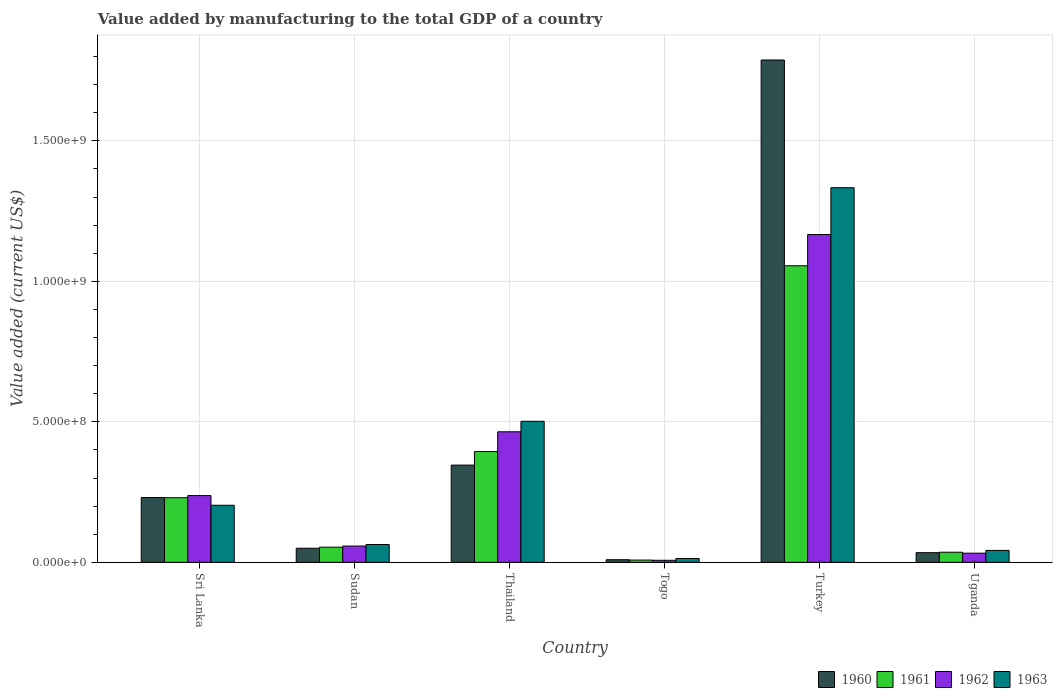Are the number of bars on each tick of the X-axis equal?
Provide a short and direct response. Yes. How many bars are there on the 4th tick from the left?
Your answer should be very brief. 4. How many bars are there on the 2nd tick from the right?
Offer a terse response. 4. What is the label of the 5th group of bars from the left?
Your answer should be very brief. Turkey. In how many cases, is the number of bars for a given country not equal to the number of legend labels?
Your answer should be compact. 0. What is the value added by manufacturing to the total GDP in 1961 in Togo?
Offer a very short reply. 8.15e+06. Across all countries, what is the maximum value added by manufacturing to the total GDP in 1960?
Give a very brief answer. 1.79e+09. Across all countries, what is the minimum value added by manufacturing to the total GDP in 1962?
Your response must be concise. 7.35e+06. In which country was the value added by manufacturing to the total GDP in 1960 minimum?
Offer a terse response. Togo. What is the total value added by manufacturing to the total GDP in 1962 in the graph?
Offer a terse response. 1.97e+09. What is the difference between the value added by manufacturing to the total GDP in 1962 in Sudan and that in Turkey?
Offer a terse response. -1.11e+09. What is the difference between the value added by manufacturing to the total GDP in 1963 in Sri Lanka and the value added by manufacturing to the total GDP in 1961 in Togo?
Offer a very short reply. 1.95e+08. What is the average value added by manufacturing to the total GDP in 1962 per country?
Make the answer very short. 3.28e+08. What is the difference between the value added by manufacturing to the total GDP of/in 1963 and value added by manufacturing to the total GDP of/in 1962 in Turkey?
Offer a terse response. 1.67e+08. What is the ratio of the value added by manufacturing to the total GDP in 1961 in Sri Lanka to that in Sudan?
Your answer should be very brief. 4.26. Is the value added by manufacturing to the total GDP in 1962 in Sri Lanka less than that in Togo?
Keep it short and to the point. No. What is the difference between the highest and the second highest value added by manufacturing to the total GDP in 1961?
Your answer should be very brief. -6.61e+08. What is the difference between the highest and the lowest value added by manufacturing to the total GDP in 1963?
Make the answer very short. 1.32e+09. In how many countries, is the value added by manufacturing to the total GDP in 1963 greater than the average value added by manufacturing to the total GDP in 1963 taken over all countries?
Make the answer very short. 2. Is it the case that in every country, the sum of the value added by manufacturing to the total GDP in 1963 and value added by manufacturing to the total GDP in 1961 is greater than the sum of value added by manufacturing to the total GDP in 1962 and value added by manufacturing to the total GDP in 1960?
Your answer should be compact. No. What does the 3rd bar from the left in Togo represents?
Make the answer very short. 1962. What does the 3rd bar from the right in Uganda represents?
Your answer should be very brief. 1961. Is it the case that in every country, the sum of the value added by manufacturing to the total GDP in 1961 and value added by manufacturing to the total GDP in 1962 is greater than the value added by manufacturing to the total GDP in 1963?
Provide a short and direct response. Yes. How many bars are there?
Provide a short and direct response. 24. Are all the bars in the graph horizontal?
Your answer should be very brief. No. How many countries are there in the graph?
Make the answer very short. 6. What is the difference between two consecutive major ticks on the Y-axis?
Give a very brief answer. 5.00e+08. Are the values on the major ticks of Y-axis written in scientific E-notation?
Ensure brevity in your answer.  Yes. Where does the legend appear in the graph?
Ensure brevity in your answer.  Bottom right. How are the legend labels stacked?
Your answer should be very brief. Horizontal. What is the title of the graph?
Give a very brief answer. Value added by manufacturing to the total GDP of a country. Does "2003" appear as one of the legend labels in the graph?
Make the answer very short. No. What is the label or title of the Y-axis?
Keep it short and to the point. Value added (current US$). What is the Value added (current US$) of 1960 in Sri Lanka?
Ensure brevity in your answer.  2.31e+08. What is the Value added (current US$) in 1961 in Sri Lanka?
Your answer should be very brief. 2.30e+08. What is the Value added (current US$) of 1962 in Sri Lanka?
Offer a terse response. 2.38e+08. What is the Value added (current US$) of 1963 in Sri Lanka?
Offer a terse response. 2.03e+08. What is the Value added (current US$) in 1960 in Sudan?
Give a very brief answer. 5.03e+07. What is the Value added (current US$) in 1961 in Sudan?
Your answer should be very brief. 5.40e+07. What is the Value added (current US$) of 1962 in Sudan?
Your response must be concise. 5.80e+07. What is the Value added (current US$) in 1963 in Sudan?
Offer a very short reply. 6.35e+07. What is the Value added (current US$) in 1960 in Thailand?
Offer a terse response. 3.46e+08. What is the Value added (current US$) of 1961 in Thailand?
Give a very brief answer. 3.94e+08. What is the Value added (current US$) of 1962 in Thailand?
Keep it short and to the point. 4.65e+08. What is the Value added (current US$) of 1963 in Thailand?
Your answer should be very brief. 5.02e+08. What is the Value added (current US$) in 1960 in Togo?
Keep it short and to the point. 9.38e+06. What is the Value added (current US$) of 1961 in Togo?
Ensure brevity in your answer.  8.15e+06. What is the Value added (current US$) in 1962 in Togo?
Offer a very short reply. 7.35e+06. What is the Value added (current US$) in 1963 in Togo?
Make the answer very short. 1.39e+07. What is the Value added (current US$) of 1960 in Turkey?
Your answer should be very brief. 1.79e+09. What is the Value added (current US$) in 1961 in Turkey?
Provide a short and direct response. 1.06e+09. What is the Value added (current US$) of 1962 in Turkey?
Your response must be concise. 1.17e+09. What is the Value added (current US$) of 1963 in Turkey?
Provide a succinct answer. 1.33e+09. What is the Value added (current US$) in 1960 in Uganda?
Your response must be concise. 3.45e+07. What is the Value added (current US$) in 1961 in Uganda?
Make the answer very short. 3.60e+07. What is the Value added (current US$) in 1962 in Uganda?
Offer a very short reply. 3.26e+07. What is the Value added (current US$) in 1963 in Uganda?
Provide a succinct answer. 4.25e+07. Across all countries, what is the maximum Value added (current US$) in 1960?
Your response must be concise. 1.79e+09. Across all countries, what is the maximum Value added (current US$) of 1961?
Provide a succinct answer. 1.06e+09. Across all countries, what is the maximum Value added (current US$) in 1962?
Ensure brevity in your answer.  1.17e+09. Across all countries, what is the maximum Value added (current US$) in 1963?
Ensure brevity in your answer.  1.33e+09. Across all countries, what is the minimum Value added (current US$) of 1960?
Give a very brief answer. 9.38e+06. Across all countries, what is the minimum Value added (current US$) of 1961?
Your answer should be very brief. 8.15e+06. Across all countries, what is the minimum Value added (current US$) in 1962?
Make the answer very short. 7.35e+06. Across all countries, what is the minimum Value added (current US$) of 1963?
Your answer should be compact. 1.39e+07. What is the total Value added (current US$) in 1960 in the graph?
Provide a succinct answer. 2.46e+09. What is the total Value added (current US$) in 1961 in the graph?
Your answer should be compact. 1.78e+09. What is the total Value added (current US$) in 1962 in the graph?
Make the answer very short. 1.97e+09. What is the total Value added (current US$) of 1963 in the graph?
Offer a terse response. 2.16e+09. What is the difference between the Value added (current US$) of 1960 in Sri Lanka and that in Sudan?
Offer a terse response. 1.80e+08. What is the difference between the Value added (current US$) of 1961 in Sri Lanka and that in Sudan?
Your response must be concise. 1.76e+08. What is the difference between the Value added (current US$) in 1962 in Sri Lanka and that in Sudan?
Your answer should be compact. 1.80e+08. What is the difference between the Value added (current US$) of 1963 in Sri Lanka and that in Sudan?
Your answer should be compact. 1.40e+08. What is the difference between the Value added (current US$) in 1960 in Sri Lanka and that in Thailand?
Provide a succinct answer. -1.15e+08. What is the difference between the Value added (current US$) of 1961 in Sri Lanka and that in Thailand?
Your response must be concise. -1.64e+08. What is the difference between the Value added (current US$) of 1962 in Sri Lanka and that in Thailand?
Your answer should be compact. -2.27e+08. What is the difference between the Value added (current US$) of 1963 in Sri Lanka and that in Thailand?
Your answer should be compact. -2.99e+08. What is the difference between the Value added (current US$) of 1960 in Sri Lanka and that in Togo?
Ensure brevity in your answer.  2.21e+08. What is the difference between the Value added (current US$) in 1961 in Sri Lanka and that in Togo?
Your answer should be compact. 2.22e+08. What is the difference between the Value added (current US$) in 1962 in Sri Lanka and that in Togo?
Make the answer very short. 2.30e+08. What is the difference between the Value added (current US$) of 1963 in Sri Lanka and that in Togo?
Your answer should be compact. 1.89e+08. What is the difference between the Value added (current US$) in 1960 in Sri Lanka and that in Turkey?
Keep it short and to the point. -1.56e+09. What is the difference between the Value added (current US$) of 1961 in Sri Lanka and that in Turkey?
Offer a terse response. -8.26e+08. What is the difference between the Value added (current US$) of 1962 in Sri Lanka and that in Turkey?
Your response must be concise. -9.29e+08. What is the difference between the Value added (current US$) in 1963 in Sri Lanka and that in Turkey?
Keep it short and to the point. -1.13e+09. What is the difference between the Value added (current US$) in 1960 in Sri Lanka and that in Uganda?
Offer a terse response. 1.96e+08. What is the difference between the Value added (current US$) in 1961 in Sri Lanka and that in Uganda?
Your answer should be very brief. 1.94e+08. What is the difference between the Value added (current US$) of 1962 in Sri Lanka and that in Uganda?
Offer a terse response. 2.05e+08. What is the difference between the Value added (current US$) in 1963 in Sri Lanka and that in Uganda?
Offer a terse response. 1.61e+08. What is the difference between the Value added (current US$) in 1960 in Sudan and that in Thailand?
Provide a short and direct response. -2.96e+08. What is the difference between the Value added (current US$) in 1961 in Sudan and that in Thailand?
Make the answer very short. -3.40e+08. What is the difference between the Value added (current US$) of 1962 in Sudan and that in Thailand?
Your response must be concise. -4.07e+08. What is the difference between the Value added (current US$) of 1963 in Sudan and that in Thailand?
Give a very brief answer. -4.39e+08. What is the difference between the Value added (current US$) of 1960 in Sudan and that in Togo?
Keep it short and to the point. 4.09e+07. What is the difference between the Value added (current US$) of 1961 in Sudan and that in Togo?
Offer a very short reply. 4.58e+07. What is the difference between the Value added (current US$) of 1962 in Sudan and that in Togo?
Offer a terse response. 5.07e+07. What is the difference between the Value added (current US$) of 1963 in Sudan and that in Togo?
Make the answer very short. 4.96e+07. What is the difference between the Value added (current US$) of 1960 in Sudan and that in Turkey?
Offer a terse response. -1.74e+09. What is the difference between the Value added (current US$) of 1961 in Sudan and that in Turkey?
Ensure brevity in your answer.  -1.00e+09. What is the difference between the Value added (current US$) of 1962 in Sudan and that in Turkey?
Your response must be concise. -1.11e+09. What is the difference between the Value added (current US$) of 1963 in Sudan and that in Turkey?
Keep it short and to the point. -1.27e+09. What is the difference between the Value added (current US$) in 1960 in Sudan and that in Uganda?
Give a very brief answer. 1.58e+07. What is the difference between the Value added (current US$) of 1961 in Sudan and that in Uganda?
Provide a succinct answer. 1.80e+07. What is the difference between the Value added (current US$) in 1962 in Sudan and that in Uganda?
Offer a terse response. 2.54e+07. What is the difference between the Value added (current US$) in 1963 in Sudan and that in Uganda?
Offer a very short reply. 2.10e+07. What is the difference between the Value added (current US$) in 1960 in Thailand and that in Togo?
Offer a terse response. 3.37e+08. What is the difference between the Value added (current US$) in 1961 in Thailand and that in Togo?
Ensure brevity in your answer.  3.86e+08. What is the difference between the Value added (current US$) in 1962 in Thailand and that in Togo?
Provide a short and direct response. 4.57e+08. What is the difference between the Value added (current US$) of 1963 in Thailand and that in Togo?
Ensure brevity in your answer.  4.88e+08. What is the difference between the Value added (current US$) of 1960 in Thailand and that in Turkey?
Offer a very short reply. -1.44e+09. What is the difference between the Value added (current US$) of 1961 in Thailand and that in Turkey?
Offer a terse response. -6.61e+08. What is the difference between the Value added (current US$) of 1962 in Thailand and that in Turkey?
Offer a terse response. -7.02e+08. What is the difference between the Value added (current US$) of 1963 in Thailand and that in Turkey?
Offer a very short reply. -8.31e+08. What is the difference between the Value added (current US$) in 1960 in Thailand and that in Uganda?
Keep it short and to the point. 3.12e+08. What is the difference between the Value added (current US$) of 1961 in Thailand and that in Uganda?
Offer a terse response. 3.58e+08. What is the difference between the Value added (current US$) of 1962 in Thailand and that in Uganda?
Offer a very short reply. 4.32e+08. What is the difference between the Value added (current US$) in 1963 in Thailand and that in Uganda?
Offer a very short reply. 4.60e+08. What is the difference between the Value added (current US$) of 1960 in Togo and that in Turkey?
Your answer should be very brief. -1.78e+09. What is the difference between the Value added (current US$) of 1961 in Togo and that in Turkey?
Provide a succinct answer. -1.05e+09. What is the difference between the Value added (current US$) in 1962 in Togo and that in Turkey?
Your response must be concise. -1.16e+09. What is the difference between the Value added (current US$) in 1963 in Togo and that in Turkey?
Offer a terse response. -1.32e+09. What is the difference between the Value added (current US$) of 1960 in Togo and that in Uganda?
Make the answer very short. -2.51e+07. What is the difference between the Value added (current US$) of 1961 in Togo and that in Uganda?
Your answer should be compact. -2.79e+07. What is the difference between the Value added (current US$) in 1962 in Togo and that in Uganda?
Ensure brevity in your answer.  -2.53e+07. What is the difference between the Value added (current US$) of 1963 in Togo and that in Uganda?
Offer a very short reply. -2.86e+07. What is the difference between the Value added (current US$) in 1960 in Turkey and that in Uganda?
Make the answer very short. 1.75e+09. What is the difference between the Value added (current US$) of 1961 in Turkey and that in Uganda?
Make the answer very short. 1.02e+09. What is the difference between the Value added (current US$) in 1962 in Turkey and that in Uganda?
Ensure brevity in your answer.  1.13e+09. What is the difference between the Value added (current US$) of 1963 in Turkey and that in Uganda?
Provide a succinct answer. 1.29e+09. What is the difference between the Value added (current US$) in 1960 in Sri Lanka and the Value added (current US$) in 1961 in Sudan?
Provide a succinct answer. 1.77e+08. What is the difference between the Value added (current US$) in 1960 in Sri Lanka and the Value added (current US$) in 1962 in Sudan?
Make the answer very short. 1.73e+08. What is the difference between the Value added (current US$) of 1960 in Sri Lanka and the Value added (current US$) of 1963 in Sudan?
Your answer should be compact. 1.67e+08. What is the difference between the Value added (current US$) in 1961 in Sri Lanka and the Value added (current US$) in 1962 in Sudan?
Your response must be concise. 1.72e+08. What is the difference between the Value added (current US$) of 1961 in Sri Lanka and the Value added (current US$) of 1963 in Sudan?
Your answer should be very brief. 1.67e+08. What is the difference between the Value added (current US$) of 1962 in Sri Lanka and the Value added (current US$) of 1963 in Sudan?
Offer a very short reply. 1.74e+08. What is the difference between the Value added (current US$) in 1960 in Sri Lanka and the Value added (current US$) in 1961 in Thailand?
Make the answer very short. -1.64e+08. What is the difference between the Value added (current US$) in 1960 in Sri Lanka and the Value added (current US$) in 1962 in Thailand?
Your answer should be compact. -2.34e+08. What is the difference between the Value added (current US$) of 1960 in Sri Lanka and the Value added (current US$) of 1963 in Thailand?
Give a very brief answer. -2.71e+08. What is the difference between the Value added (current US$) in 1961 in Sri Lanka and the Value added (current US$) in 1962 in Thailand?
Provide a succinct answer. -2.35e+08. What is the difference between the Value added (current US$) in 1961 in Sri Lanka and the Value added (current US$) in 1963 in Thailand?
Make the answer very short. -2.72e+08. What is the difference between the Value added (current US$) of 1962 in Sri Lanka and the Value added (current US$) of 1963 in Thailand?
Provide a short and direct response. -2.64e+08. What is the difference between the Value added (current US$) in 1960 in Sri Lanka and the Value added (current US$) in 1961 in Togo?
Your response must be concise. 2.23e+08. What is the difference between the Value added (current US$) in 1960 in Sri Lanka and the Value added (current US$) in 1962 in Togo?
Offer a very short reply. 2.23e+08. What is the difference between the Value added (current US$) of 1960 in Sri Lanka and the Value added (current US$) of 1963 in Togo?
Provide a short and direct response. 2.17e+08. What is the difference between the Value added (current US$) of 1961 in Sri Lanka and the Value added (current US$) of 1962 in Togo?
Ensure brevity in your answer.  2.23e+08. What is the difference between the Value added (current US$) of 1961 in Sri Lanka and the Value added (current US$) of 1963 in Togo?
Offer a very short reply. 2.16e+08. What is the difference between the Value added (current US$) in 1962 in Sri Lanka and the Value added (current US$) in 1963 in Togo?
Your response must be concise. 2.24e+08. What is the difference between the Value added (current US$) in 1960 in Sri Lanka and the Value added (current US$) in 1961 in Turkey?
Ensure brevity in your answer.  -8.25e+08. What is the difference between the Value added (current US$) of 1960 in Sri Lanka and the Value added (current US$) of 1962 in Turkey?
Give a very brief answer. -9.36e+08. What is the difference between the Value added (current US$) in 1960 in Sri Lanka and the Value added (current US$) in 1963 in Turkey?
Keep it short and to the point. -1.10e+09. What is the difference between the Value added (current US$) in 1961 in Sri Lanka and the Value added (current US$) in 1962 in Turkey?
Ensure brevity in your answer.  -9.37e+08. What is the difference between the Value added (current US$) in 1961 in Sri Lanka and the Value added (current US$) in 1963 in Turkey?
Provide a short and direct response. -1.10e+09. What is the difference between the Value added (current US$) in 1962 in Sri Lanka and the Value added (current US$) in 1963 in Turkey?
Provide a short and direct response. -1.10e+09. What is the difference between the Value added (current US$) of 1960 in Sri Lanka and the Value added (current US$) of 1961 in Uganda?
Keep it short and to the point. 1.95e+08. What is the difference between the Value added (current US$) in 1960 in Sri Lanka and the Value added (current US$) in 1962 in Uganda?
Keep it short and to the point. 1.98e+08. What is the difference between the Value added (current US$) of 1960 in Sri Lanka and the Value added (current US$) of 1963 in Uganda?
Provide a short and direct response. 1.88e+08. What is the difference between the Value added (current US$) in 1961 in Sri Lanka and the Value added (current US$) in 1962 in Uganda?
Ensure brevity in your answer.  1.97e+08. What is the difference between the Value added (current US$) in 1961 in Sri Lanka and the Value added (current US$) in 1963 in Uganda?
Provide a succinct answer. 1.88e+08. What is the difference between the Value added (current US$) of 1962 in Sri Lanka and the Value added (current US$) of 1963 in Uganda?
Offer a very short reply. 1.95e+08. What is the difference between the Value added (current US$) in 1960 in Sudan and the Value added (current US$) in 1961 in Thailand?
Offer a terse response. -3.44e+08. What is the difference between the Value added (current US$) of 1960 in Sudan and the Value added (current US$) of 1962 in Thailand?
Keep it short and to the point. -4.14e+08. What is the difference between the Value added (current US$) in 1960 in Sudan and the Value added (current US$) in 1963 in Thailand?
Your answer should be very brief. -4.52e+08. What is the difference between the Value added (current US$) in 1961 in Sudan and the Value added (current US$) in 1962 in Thailand?
Ensure brevity in your answer.  -4.11e+08. What is the difference between the Value added (current US$) of 1961 in Sudan and the Value added (current US$) of 1963 in Thailand?
Offer a terse response. -4.48e+08. What is the difference between the Value added (current US$) in 1962 in Sudan and the Value added (current US$) in 1963 in Thailand?
Ensure brevity in your answer.  -4.44e+08. What is the difference between the Value added (current US$) of 1960 in Sudan and the Value added (current US$) of 1961 in Togo?
Your response must be concise. 4.21e+07. What is the difference between the Value added (current US$) of 1960 in Sudan and the Value added (current US$) of 1962 in Togo?
Provide a succinct answer. 4.29e+07. What is the difference between the Value added (current US$) in 1960 in Sudan and the Value added (current US$) in 1963 in Togo?
Your answer should be compact. 3.64e+07. What is the difference between the Value added (current US$) of 1961 in Sudan and the Value added (current US$) of 1962 in Togo?
Offer a terse response. 4.66e+07. What is the difference between the Value added (current US$) of 1961 in Sudan and the Value added (current US$) of 1963 in Togo?
Provide a succinct answer. 4.01e+07. What is the difference between the Value added (current US$) of 1962 in Sudan and the Value added (current US$) of 1963 in Togo?
Your answer should be compact. 4.41e+07. What is the difference between the Value added (current US$) of 1960 in Sudan and the Value added (current US$) of 1961 in Turkey?
Ensure brevity in your answer.  -1.01e+09. What is the difference between the Value added (current US$) in 1960 in Sudan and the Value added (current US$) in 1962 in Turkey?
Offer a very short reply. -1.12e+09. What is the difference between the Value added (current US$) of 1960 in Sudan and the Value added (current US$) of 1963 in Turkey?
Offer a terse response. -1.28e+09. What is the difference between the Value added (current US$) in 1961 in Sudan and the Value added (current US$) in 1962 in Turkey?
Make the answer very short. -1.11e+09. What is the difference between the Value added (current US$) of 1961 in Sudan and the Value added (current US$) of 1963 in Turkey?
Your response must be concise. -1.28e+09. What is the difference between the Value added (current US$) of 1962 in Sudan and the Value added (current US$) of 1963 in Turkey?
Provide a succinct answer. -1.28e+09. What is the difference between the Value added (current US$) in 1960 in Sudan and the Value added (current US$) in 1961 in Uganda?
Your answer should be very brief. 1.42e+07. What is the difference between the Value added (current US$) of 1960 in Sudan and the Value added (current US$) of 1962 in Uganda?
Keep it short and to the point. 1.76e+07. What is the difference between the Value added (current US$) of 1960 in Sudan and the Value added (current US$) of 1963 in Uganda?
Offer a terse response. 7.75e+06. What is the difference between the Value added (current US$) in 1961 in Sudan and the Value added (current US$) in 1962 in Uganda?
Offer a terse response. 2.14e+07. What is the difference between the Value added (current US$) in 1961 in Sudan and the Value added (current US$) in 1963 in Uganda?
Provide a succinct answer. 1.15e+07. What is the difference between the Value added (current US$) in 1962 in Sudan and the Value added (current US$) in 1963 in Uganda?
Keep it short and to the point. 1.55e+07. What is the difference between the Value added (current US$) of 1960 in Thailand and the Value added (current US$) of 1961 in Togo?
Give a very brief answer. 3.38e+08. What is the difference between the Value added (current US$) in 1960 in Thailand and the Value added (current US$) in 1962 in Togo?
Provide a short and direct response. 3.39e+08. What is the difference between the Value added (current US$) in 1960 in Thailand and the Value added (current US$) in 1963 in Togo?
Ensure brevity in your answer.  3.32e+08. What is the difference between the Value added (current US$) in 1961 in Thailand and the Value added (current US$) in 1962 in Togo?
Give a very brief answer. 3.87e+08. What is the difference between the Value added (current US$) in 1961 in Thailand and the Value added (current US$) in 1963 in Togo?
Offer a terse response. 3.80e+08. What is the difference between the Value added (current US$) of 1962 in Thailand and the Value added (current US$) of 1963 in Togo?
Ensure brevity in your answer.  4.51e+08. What is the difference between the Value added (current US$) of 1960 in Thailand and the Value added (current US$) of 1961 in Turkey?
Give a very brief answer. -7.09e+08. What is the difference between the Value added (current US$) in 1960 in Thailand and the Value added (current US$) in 1962 in Turkey?
Offer a very short reply. -8.21e+08. What is the difference between the Value added (current US$) in 1960 in Thailand and the Value added (current US$) in 1963 in Turkey?
Your response must be concise. -9.87e+08. What is the difference between the Value added (current US$) of 1961 in Thailand and the Value added (current US$) of 1962 in Turkey?
Ensure brevity in your answer.  -7.72e+08. What is the difference between the Value added (current US$) in 1961 in Thailand and the Value added (current US$) in 1963 in Turkey?
Your answer should be very brief. -9.39e+08. What is the difference between the Value added (current US$) of 1962 in Thailand and the Value added (current US$) of 1963 in Turkey?
Provide a succinct answer. -8.69e+08. What is the difference between the Value added (current US$) in 1960 in Thailand and the Value added (current US$) in 1961 in Uganda?
Your response must be concise. 3.10e+08. What is the difference between the Value added (current US$) in 1960 in Thailand and the Value added (current US$) in 1962 in Uganda?
Offer a terse response. 3.13e+08. What is the difference between the Value added (current US$) of 1960 in Thailand and the Value added (current US$) of 1963 in Uganda?
Ensure brevity in your answer.  3.04e+08. What is the difference between the Value added (current US$) in 1961 in Thailand and the Value added (current US$) in 1962 in Uganda?
Your answer should be compact. 3.62e+08. What is the difference between the Value added (current US$) in 1961 in Thailand and the Value added (current US$) in 1963 in Uganda?
Give a very brief answer. 3.52e+08. What is the difference between the Value added (current US$) in 1962 in Thailand and the Value added (current US$) in 1963 in Uganda?
Provide a succinct answer. 4.22e+08. What is the difference between the Value added (current US$) in 1960 in Togo and the Value added (current US$) in 1961 in Turkey?
Ensure brevity in your answer.  -1.05e+09. What is the difference between the Value added (current US$) in 1960 in Togo and the Value added (current US$) in 1962 in Turkey?
Ensure brevity in your answer.  -1.16e+09. What is the difference between the Value added (current US$) in 1960 in Togo and the Value added (current US$) in 1963 in Turkey?
Ensure brevity in your answer.  -1.32e+09. What is the difference between the Value added (current US$) of 1961 in Togo and the Value added (current US$) of 1962 in Turkey?
Offer a very short reply. -1.16e+09. What is the difference between the Value added (current US$) in 1961 in Togo and the Value added (current US$) in 1963 in Turkey?
Your answer should be compact. -1.33e+09. What is the difference between the Value added (current US$) of 1962 in Togo and the Value added (current US$) of 1963 in Turkey?
Make the answer very short. -1.33e+09. What is the difference between the Value added (current US$) of 1960 in Togo and the Value added (current US$) of 1961 in Uganda?
Give a very brief answer. -2.66e+07. What is the difference between the Value added (current US$) in 1960 in Togo and the Value added (current US$) in 1962 in Uganda?
Give a very brief answer. -2.33e+07. What is the difference between the Value added (current US$) of 1960 in Togo and the Value added (current US$) of 1963 in Uganda?
Make the answer very short. -3.31e+07. What is the difference between the Value added (current US$) of 1961 in Togo and the Value added (current US$) of 1962 in Uganda?
Offer a very short reply. -2.45e+07. What is the difference between the Value added (current US$) in 1961 in Togo and the Value added (current US$) in 1963 in Uganda?
Provide a succinct answer. -3.44e+07. What is the difference between the Value added (current US$) in 1962 in Togo and the Value added (current US$) in 1963 in Uganda?
Ensure brevity in your answer.  -3.52e+07. What is the difference between the Value added (current US$) of 1960 in Turkey and the Value added (current US$) of 1961 in Uganda?
Provide a short and direct response. 1.75e+09. What is the difference between the Value added (current US$) of 1960 in Turkey and the Value added (current US$) of 1962 in Uganda?
Make the answer very short. 1.76e+09. What is the difference between the Value added (current US$) in 1960 in Turkey and the Value added (current US$) in 1963 in Uganda?
Provide a short and direct response. 1.75e+09. What is the difference between the Value added (current US$) in 1961 in Turkey and the Value added (current US$) in 1962 in Uganda?
Your answer should be very brief. 1.02e+09. What is the difference between the Value added (current US$) in 1961 in Turkey and the Value added (current US$) in 1963 in Uganda?
Make the answer very short. 1.01e+09. What is the difference between the Value added (current US$) of 1962 in Turkey and the Value added (current US$) of 1963 in Uganda?
Provide a succinct answer. 1.12e+09. What is the average Value added (current US$) of 1960 per country?
Make the answer very short. 4.10e+08. What is the average Value added (current US$) of 1961 per country?
Provide a short and direct response. 2.96e+08. What is the average Value added (current US$) in 1962 per country?
Provide a short and direct response. 3.28e+08. What is the average Value added (current US$) of 1963 per country?
Ensure brevity in your answer.  3.60e+08. What is the difference between the Value added (current US$) of 1960 and Value added (current US$) of 1961 in Sri Lanka?
Your answer should be very brief. 6.30e+05. What is the difference between the Value added (current US$) in 1960 and Value added (current US$) in 1962 in Sri Lanka?
Ensure brevity in your answer.  -6.98e+06. What is the difference between the Value added (current US$) of 1960 and Value added (current US$) of 1963 in Sri Lanka?
Your response must be concise. 2.75e+07. What is the difference between the Value added (current US$) in 1961 and Value added (current US$) in 1962 in Sri Lanka?
Keep it short and to the point. -7.61e+06. What is the difference between the Value added (current US$) in 1961 and Value added (current US$) in 1963 in Sri Lanka?
Offer a very short reply. 2.68e+07. What is the difference between the Value added (current US$) of 1962 and Value added (current US$) of 1963 in Sri Lanka?
Your answer should be compact. 3.45e+07. What is the difference between the Value added (current US$) in 1960 and Value added (current US$) in 1961 in Sudan?
Ensure brevity in your answer.  -3.73e+06. What is the difference between the Value added (current US$) in 1960 and Value added (current US$) in 1962 in Sudan?
Offer a terse response. -7.75e+06. What is the difference between the Value added (current US$) in 1960 and Value added (current US$) in 1963 in Sudan?
Give a very brief answer. -1.32e+07. What is the difference between the Value added (current US$) of 1961 and Value added (current US$) of 1962 in Sudan?
Offer a terse response. -4.02e+06. What is the difference between the Value added (current US$) in 1961 and Value added (current US$) in 1963 in Sudan?
Offer a terse response. -9.48e+06. What is the difference between the Value added (current US$) of 1962 and Value added (current US$) of 1963 in Sudan?
Provide a succinct answer. -5.46e+06. What is the difference between the Value added (current US$) of 1960 and Value added (current US$) of 1961 in Thailand?
Provide a short and direct response. -4.81e+07. What is the difference between the Value added (current US$) in 1960 and Value added (current US$) in 1962 in Thailand?
Ensure brevity in your answer.  -1.19e+08. What is the difference between the Value added (current US$) of 1960 and Value added (current US$) of 1963 in Thailand?
Your response must be concise. -1.56e+08. What is the difference between the Value added (current US$) of 1961 and Value added (current US$) of 1962 in Thailand?
Make the answer very short. -7.05e+07. What is the difference between the Value added (current US$) of 1961 and Value added (current US$) of 1963 in Thailand?
Give a very brief answer. -1.08e+08. What is the difference between the Value added (current US$) in 1962 and Value added (current US$) in 1963 in Thailand?
Provide a succinct answer. -3.73e+07. What is the difference between the Value added (current US$) in 1960 and Value added (current US$) in 1961 in Togo?
Your answer should be compact. 1.23e+06. What is the difference between the Value added (current US$) in 1960 and Value added (current US$) in 1962 in Togo?
Give a very brief answer. 2.03e+06. What is the difference between the Value added (current US$) of 1960 and Value added (current US$) of 1963 in Togo?
Keep it short and to the point. -4.50e+06. What is the difference between the Value added (current US$) of 1961 and Value added (current US$) of 1962 in Togo?
Keep it short and to the point. 8.08e+05. What is the difference between the Value added (current US$) of 1961 and Value added (current US$) of 1963 in Togo?
Keep it short and to the point. -5.72e+06. What is the difference between the Value added (current US$) of 1962 and Value added (current US$) of 1963 in Togo?
Your answer should be very brief. -6.53e+06. What is the difference between the Value added (current US$) of 1960 and Value added (current US$) of 1961 in Turkey?
Make the answer very short. 7.32e+08. What is the difference between the Value added (current US$) of 1960 and Value added (current US$) of 1962 in Turkey?
Your answer should be very brief. 6.21e+08. What is the difference between the Value added (current US$) in 1960 and Value added (current US$) in 1963 in Turkey?
Provide a succinct answer. 4.55e+08. What is the difference between the Value added (current US$) in 1961 and Value added (current US$) in 1962 in Turkey?
Offer a terse response. -1.11e+08. What is the difference between the Value added (current US$) in 1961 and Value added (current US$) in 1963 in Turkey?
Your answer should be very brief. -2.78e+08. What is the difference between the Value added (current US$) in 1962 and Value added (current US$) in 1963 in Turkey?
Give a very brief answer. -1.67e+08. What is the difference between the Value added (current US$) in 1960 and Value added (current US$) in 1961 in Uganda?
Provide a short and direct response. -1.54e+06. What is the difference between the Value added (current US$) in 1960 and Value added (current US$) in 1962 in Uganda?
Your answer should be very brief. 1.85e+06. What is the difference between the Value added (current US$) in 1960 and Value added (current US$) in 1963 in Uganda?
Your response must be concise. -8.03e+06. What is the difference between the Value added (current US$) of 1961 and Value added (current US$) of 1962 in Uganda?
Give a very brief answer. 3.39e+06. What is the difference between the Value added (current US$) of 1961 and Value added (current US$) of 1963 in Uganda?
Offer a terse response. -6.48e+06. What is the difference between the Value added (current US$) of 1962 and Value added (current US$) of 1963 in Uganda?
Ensure brevity in your answer.  -9.87e+06. What is the ratio of the Value added (current US$) of 1960 in Sri Lanka to that in Sudan?
Provide a succinct answer. 4.59. What is the ratio of the Value added (current US$) of 1961 in Sri Lanka to that in Sudan?
Keep it short and to the point. 4.26. What is the ratio of the Value added (current US$) in 1962 in Sri Lanka to that in Sudan?
Offer a terse response. 4.1. What is the ratio of the Value added (current US$) of 1963 in Sri Lanka to that in Sudan?
Make the answer very short. 3.2. What is the ratio of the Value added (current US$) in 1960 in Sri Lanka to that in Thailand?
Offer a very short reply. 0.67. What is the ratio of the Value added (current US$) of 1961 in Sri Lanka to that in Thailand?
Your answer should be very brief. 0.58. What is the ratio of the Value added (current US$) in 1962 in Sri Lanka to that in Thailand?
Ensure brevity in your answer.  0.51. What is the ratio of the Value added (current US$) in 1963 in Sri Lanka to that in Thailand?
Your response must be concise. 0.4. What is the ratio of the Value added (current US$) in 1960 in Sri Lanka to that in Togo?
Provide a succinct answer. 24.59. What is the ratio of the Value added (current US$) in 1961 in Sri Lanka to that in Togo?
Your answer should be very brief. 28.21. What is the ratio of the Value added (current US$) in 1962 in Sri Lanka to that in Togo?
Provide a short and direct response. 32.35. What is the ratio of the Value added (current US$) of 1963 in Sri Lanka to that in Togo?
Make the answer very short. 14.64. What is the ratio of the Value added (current US$) of 1960 in Sri Lanka to that in Turkey?
Make the answer very short. 0.13. What is the ratio of the Value added (current US$) of 1961 in Sri Lanka to that in Turkey?
Offer a very short reply. 0.22. What is the ratio of the Value added (current US$) in 1962 in Sri Lanka to that in Turkey?
Offer a very short reply. 0.2. What is the ratio of the Value added (current US$) in 1963 in Sri Lanka to that in Turkey?
Offer a terse response. 0.15. What is the ratio of the Value added (current US$) in 1960 in Sri Lanka to that in Uganda?
Provide a succinct answer. 6.69. What is the ratio of the Value added (current US$) of 1961 in Sri Lanka to that in Uganda?
Your answer should be compact. 6.39. What is the ratio of the Value added (current US$) in 1962 in Sri Lanka to that in Uganda?
Provide a short and direct response. 7.28. What is the ratio of the Value added (current US$) in 1963 in Sri Lanka to that in Uganda?
Your answer should be compact. 4.78. What is the ratio of the Value added (current US$) in 1960 in Sudan to that in Thailand?
Your answer should be compact. 0.15. What is the ratio of the Value added (current US$) in 1961 in Sudan to that in Thailand?
Keep it short and to the point. 0.14. What is the ratio of the Value added (current US$) in 1962 in Sudan to that in Thailand?
Ensure brevity in your answer.  0.12. What is the ratio of the Value added (current US$) of 1963 in Sudan to that in Thailand?
Provide a succinct answer. 0.13. What is the ratio of the Value added (current US$) of 1960 in Sudan to that in Togo?
Give a very brief answer. 5.36. What is the ratio of the Value added (current US$) of 1961 in Sudan to that in Togo?
Provide a short and direct response. 6.62. What is the ratio of the Value added (current US$) of 1962 in Sudan to that in Togo?
Provide a succinct answer. 7.9. What is the ratio of the Value added (current US$) of 1963 in Sudan to that in Togo?
Provide a short and direct response. 4.57. What is the ratio of the Value added (current US$) in 1960 in Sudan to that in Turkey?
Make the answer very short. 0.03. What is the ratio of the Value added (current US$) in 1961 in Sudan to that in Turkey?
Your answer should be very brief. 0.05. What is the ratio of the Value added (current US$) of 1962 in Sudan to that in Turkey?
Your response must be concise. 0.05. What is the ratio of the Value added (current US$) of 1963 in Sudan to that in Turkey?
Ensure brevity in your answer.  0.05. What is the ratio of the Value added (current US$) of 1960 in Sudan to that in Uganda?
Offer a very short reply. 1.46. What is the ratio of the Value added (current US$) of 1961 in Sudan to that in Uganda?
Your answer should be compact. 1.5. What is the ratio of the Value added (current US$) in 1962 in Sudan to that in Uganda?
Keep it short and to the point. 1.78. What is the ratio of the Value added (current US$) of 1963 in Sudan to that in Uganda?
Offer a terse response. 1.49. What is the ratio of the Value added (current US$) of 1960 in Thailand to that in Togo?
Provide a succinct answer. 36.9. What is the ratio of the Value added (current US$) of 1961 in Thailand to that in Togo?
Give a very brief answer. 48.34. What is the ratio of the Value added (current US$) of 1962 in Thailand to that in Togo?
Make the answer very short. 63.26. What is the ratio of the Value added (current US$) in 1963 in Thailand to that in Togo?
Make the answer very short. 36.18. What is the ratio of the Value added (current US$) of 1960 in Thailand to that in Turkey?
Provide a succinct answer. 0.19. What is the ratio of the Value added (current US$) in 1961 in Thailand to that in Turkey?
Keep it short and to the point. 0.37. What is the ratio of the Value added (current US$) in 1962 in Thailand to that in Turkey?
Keep it short and to the point. 0.4. What is the ratio of the Value added (current US$) in 1963 in Thailand to that in Turkey?
Keep it short and to the point. 0.38. What is the ratio of the Value added (current US$) in 1960 in Thailand to that in Uganda?
Your answer should be very brief. 10.04. What is the ratio of the Value added (current US$) of 1961 in Thailand to that in Uganda?
Your answer should be very brief. 10.94. What is the ratio of the Value added (current US$) of 1962 in Thailand to that in Uganda?
Your answer should be compact. 14.24. What is the ratio of the Value added (current US$) in 1963 in Thailand to that in Uganda?
Offer a very short reply. 11.81. What is the ratio of the Value added (current US$) in 1960 in Togo to that in Turkey?
Your answer should be compact. 0.01. What is the ratio of the Value added (current US$) in 1961 in Togo to that in Turkey?
Keep it short and to the point. 0.01. What is the ratio of the Value added (current US$) of 1962 in Togo to that in Turkey?
Your response must be concise. 0.01. What is the ratio of the Value added (current US$) in 1963 in Togo to that in Turkey?
Offer a very short reply. 0.01. What is the ratio of the Value added (current US$) in 1960 in Togo to that in Uganda?
Give a very brief answer. 0.27. What is the ratio of the Value added (current US$) in 1961 in Togo to that in Uganda?
Ensure brevity in your answer.  0.23. What is the ratio of the Value added (current US$) of 1962 in Togo to that in Uganda?
Give a very brief answer. 0.23. What is the ratio of the Value added (current US$) in 1963 in Togo to that in Uganda?
Ensure brevity in your answer.  0.33. What is the ratio of the Value added (current US$) of 1960 in Turkey to that in Uganda?
Keep it short and to the point. 51.86. What is the ratio of the Value added (current US$) of 1961 in Turkey to that in Uganda?
Give a very brief answer. 29.3. What is the ratio of the Value added (current US$) of 1962 in Turkey to that in Uganda?
Provide a short and direct response. 35.75. What is the ratio of the Value added (current US$) of 1963 in Turkey to that in Uganda?
Make the answer very short. 31.37. What is the difference between the highest and the second highest Value added (current US$) in 1960?
Provide a succinct answer. 1.44e+09. What is the difference between the highest and the second highest Value added (current US$) of 1961?
Provide a short and direct response. 6.61e+08. What is the difference between the highest and the second highest Value added (current US$) of 1962?
Your answer should be compact. 7.02e+08. What is the difference between the highest and the second highest Value added (current US$) in 1963?
Provide a succinct answer. 8.31e+08. What is the difference between the highest and the lowest Value added (current US$) of 1960?
Your answer should be very brief. 1.78e+09. What is the difference between the highest and the lowest Value added (current US$) of 1961?
Offer a terse response. 1.05e+09. What is the difference between the highest and the lowest Value added (current US$) in 1962?
Provide a succinct answer. 1.16e+09. What is the difference between the highest and the lowest Value added (current US$) of 1963?
Offer a very short reply. 1.32e+09. 